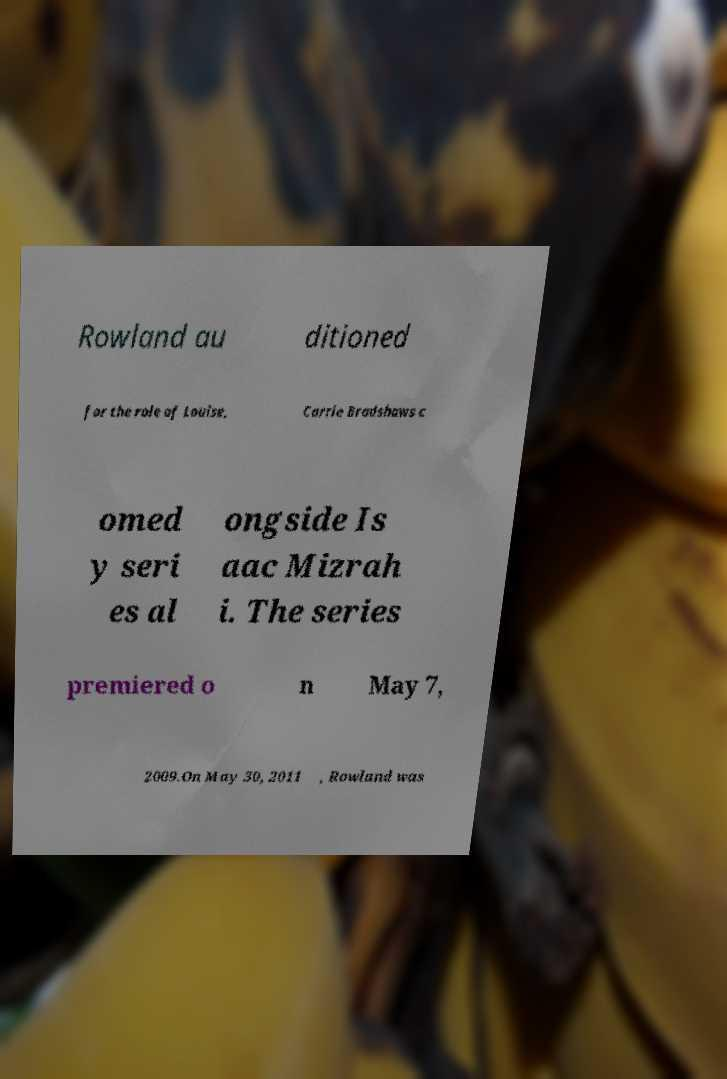Could you extract and type out the text from this image? Rowland au ditioned for the role of Louise, Carrie Bradshaws c omed y seri es al ongside Is aac Mizrah i. The series premiered o n May 7, 2009.On May 30, 2011 , Rowland was 